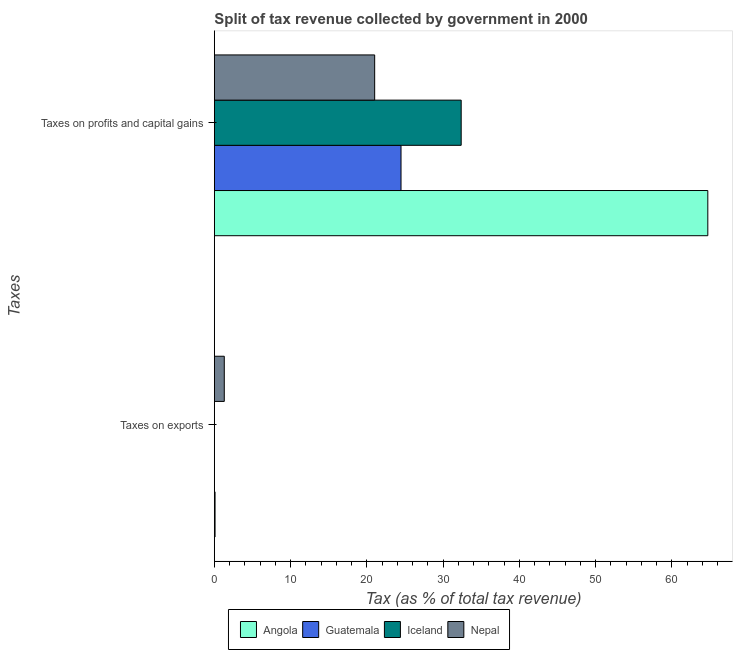How many different coloured bars are there?
Provide a short and direct response. 4. Are the number of bars per tick equal to the number of legend labels?
Keep it short and to the point. Yes. Are the number of bars on each tick of the Y-axis equal?
Give a very brief answer. Yes. How many bars are there on the 2nd tick from the top?
Make the answer very short. 4. What is the label of the 1st group of bars from the top?
Keep it short and to the point. Taxes on profits and capital gains. What is the percentage of revenue obtained from taxes on exports in Nepal?
Offer a terse response. 1.3. Across all countries, what is the maximum percentage of revenue obtained from taxes on exports?
Offer a terse response. 1.3. Across all countries, what is the minimum percentage of revenue obtained from taxes on exports?
Keep it short and to the point. 0.01. In which country was the percentage of revenue obtained from taxes on profits and capital gains maximum?
Ensure brevity in your answer.  Angola. What is the total percentage of revenue obtained from taxes on profits and capital gains in the graph?
Ensure brevity in your answer.  142.56. What is the difference between the percentage of revenue obtained from taxes on profits and capital gains in Angola and that in Iceland?
Give a very brief answer. 32.34. What is the difference between the percentage of revenue obtained from taxes on profits and capital gains in Nepal and the percentage of revenue obtained from taxes on exports in Guatemala?
Your answer should be compact. 21.01. What is the average percentage of revenue obtained from taxes on exports per country?
Make the answer very short. 0.35. What is the difference between the percentage of revenue obtained from taxes on exports and percentage of revenue obtained from taxes on profits and capital gains in Iceland?
Provide a succinct answer. -32.36. In how many countries, is the percentage of revenue obtained from taxes on exports greater than 30 %?
Your response must be concise. 0. What is the ratio of the percentage of revenue obtained from taxes on profits and capital gains in Nepal to that in Iceland?
Your answer should be very brief. 0.65. In how many countries, is the percentage of revenue obtained from taxes on profits and capital gains greater than the average percentage of revenue obtained from taxes on profits and capital gains taken over all countries?
Your answer should be compact. 1. What does the 4th bar from the top in Taxes on exports represents?
Offer a very short reply. Angola. What does the 2nd bar from the bottom in Taxes on profits and capital gains represents?
Your answer should be very brief. Guatemala. How many bars are there?
Make the answer very short. 8. Are all the bars in the graph horizontal?
Your answer should be very brief. Yes. What is the difference between two consecutive major ticks on the X-axis?
Provide a short and direct response. 10. Are the values on the major ticks of X-axis written in scientific E-notation?
Your answer should be compact. No. Does the graph contain any zero values?
Offer a terse response. No. How many legend labels are there?
Your answer should be very brief. 4. What is the title of the graph?
Give a very brief answer. Split of tax revenue collected by government in 2000. Does "Lao PDR" appear as one of the legend labels in the graph?
Your answer should be compact. No. What is the label or title of the X-axis?
Ensure brevity in your answer.  Tax (as % of total tax revenue). What is the label or title of the Y-axis?
Your answer should be very brief. Taxes. What is the Tax (as % of total tax revenue) of Angola in Taxes on exports?
Keep it short and to the point. 0.09. What is the Tax (as % of total tax revenue) of Guatemala in Taxes on exports?
Offer a terse response. 0.01. What is the Tax (as % of total tax revenue) of Iceland in Taxes on exports?
Offer a very short reply. 0.01. What is the Tax (as % of total tax revenue) in Nepal in Taxes on exports?
Keep it short and to the point. 1.3. What is the Tax (as % of total tax revenue) in Angola in Taxes on profits and capital gains?
Offer a very short reply. 64.7. What is the Tax (as % of total tax revenue) in Guatemala in Taxes on profits and capital gains?
Make the answer very short. 24.47. What is the Tax (as % of total tax revenue) in Iceland in Taxes on profits and capital gains?
Your answer should be very brief. 32.36. What is the Tax (as % of total tax revenue) in Nepal in Taxes on profits and capital gains?
Give a very brief answer. 21.02. Across all Taxes, what is the maximum Tax (as % of total tax revenue) of Angola?
Give a very brief answer. 64.7. Across all Taxes, what is the maximum Tax (as % of total tax revenue) of Guatemala?
Offer a terse response. 24.47. Across all Taxes, what is the maximum Tax (as % of total tax revenue) of Iceland?
Provide a succinct answer. 32.36. Across all Taxes, what is the maximum Tax (as % of total tax revenue) in Nepal?
Offer a very short reply. 21.02. Across all Taxes, what is the minimum Tax (as % of total tax revenue) of Angola?
Provide a succinct answer. 0.09. Across all Taxes, what is the minimum Tax (as % of total tax revenue) in Guatemala?
Make the answer very short. 0.01. Across all Taxes, what is the minimum Tax (as % of total tax revenue) in Iceland?
Make the answer very short. 0.01. Across all Taxes, what is the minimum Tax (as % of total tax revenue) of Nepal?
Make the answer very short. 1.3. What is the total Tax (as % of total tax revenue) of Angola in the graph?
Provide a succinct answer. 64.79. What is the total Tax (as % of total tax revenue) in Guatemala in the graph?
Provide a succinct answer. 24.48. What is the total Tax (as % of total tax revenue) of Iceland in the graph?
Ensure brevity in your answer.  32.37. What is the total Tax (as % of total tax revenue) in Nepal in the graph?
Make the answer very short. 22.32. What is the difference between the Tax (as % of total tax revenue) of Angola in Taxes on exports and that in Taxes on profits and capital gains?
Provide a succinct answer. -64.61. What is the difference between the Tax (as % of total tax revenue) of Guatemala in Taxes on exports and that in Taxes on profits and capital gains?
Keep it short and to the point. -24.46. What is the difference between the Tax (as % of total tax revenue) of Iceland in Taxes on exports and that in Taxes on profits and capital gains?
Make the answer very short. -32.36. What is the difference between the Tax (as % of total tax revenue) of Nepal in Taxes on exports and that in Taxes on profits and capital gains?
Ensure brevity in your answer.  -19.72. What is the difference between the Tax (as % of total tax revenue) in Angola in Taxes on exports and the Tax (as % of total tax revenue) in Guatemala in Taxes on profits and capital gains?
Your response must be concise. -24.38. What is the difference between the Tax (as % of total tax revenue) in Angola in Taxes on exports and the Tax (as % of total tax revenue) in Iceland in Taxes on profits and capital gains?
Keep it short and to the point. -32.27. What is the difference between the Tax (as % of total tax revenue) in Angola in Taxes on exports and the Tax (as % of total tax revenue) in Nepal in Taxes on profits and capital gains?
Provide a succinct answer. -20.93. What is the difference between the Tax (as % of total tax revenue) in Guatemala in Taxes on exports and the Tax (as % of total tax revenue) in Iceland in Taxes on profits and capital gains?
Provide a short and direct response. -32.35. What is the difference between the Tax (as % of total tax revenue) of Guatemala in Taxes on exports and the Tax (as % of total tax revenue) of Nepal in Taxes on profits and capital gains?
Provide a short and direct response. -21.01. What is the difference between the Tax (as % of total tax revenue) in Iceland in Taxes on exports and the Tax (as % of total tax revenue) in Nepal in Taxes on profits and capital gains?
Your response must be concise. -21.01. What is the average Tax (as % of total tax revenue) of Angola per Taxes?
Make the answer very short. 32.4. What is the average Tax (as % of total tax revenue) of Guatemala per Taxes?
Provide a succinct answer. 12.24. What is the average Tax (as % of total tax revenue) in Iceland per Taxes?
Provide a succinct answer. 16.19. What is the average Tax (as % of total tax revenue) in Nepal per Taxes?
Your answer should be very brief. 11.16. What is the difference between the Tax (as % of total tax revenue) in Angola and Tax (as % of total tax revenue) in Guatemala in Taxes on exports?
Ensure brevity in your answer.  0.08. What is the difference between the Tax (as % of total tax revenue) of Angola and Tax (as % of total tax revenue) of Iceland in Taxes on exports?
Keep it short and to the point. 0.09. What is the difference between the Tax (as % of total tax revenue) of Angola and Tax (as % of total tax revenue) of Nepal in Taxes on exports?
Provide a succinct answer. -1.21. What is the difference between the Tax (as % of total tax revenue) of Guatemala and Tax (as % of total tax revenue) of Iceland in Taxes on exports?
Your answer should be very brief. 0. What is the difference between the Tax (as % of total tax revenue) of Guatemala and Tax (as % of total tax revenue) of Nepal in Taxes on exports?
Ensure brevity in your answer.  -1.29. What is the difference between the Tax (as % of total tax revenue) of Iceland and Tax (as % of total tax revenue) of Nepal in Taxes on exports?
Your response must be concise. -1.3. What is the difference between the Tax (as % of total tax revenue) of Angola and Tax (as % of total tax revenue) of Guatemala in Taxes on profits and capital gains?
Offer a very short reply. 40.23. What is the difference between the Tax (as % of total tax revenue) in Angola and Tax (as % of total tax revenue) in Iceland in Taxes on profits and capital gains?
Ensure brevity in your answer.  32.34. What is the difference between the Tax (as % of total tax revenue) in Angola and Tax (as % of total tax revenue) in Nepal in Taxes on profits and capital gains?
Ensure brevity in your answer.  43.68. What is the difference between the Tax (as % of total tax revenue) in Guatemala and Tax (as % of total tax revenue) in Iceland in Taxes on profits and capital gains?
Make the answer very short. -7.89. What is the difference between the Tax (as % of total tax revenue) of Guatemala and Tax (as % of total tax revenue) of Nepal in Taxes on profits and capital gains?
Provide a short and direct response. 3.45. What is the difference between the Tax (as % of total tax revenue) in Iceland and Tax (as % of total tax revenue) in Nepal in Taxes on profits and capital gains?
Your response must be concise. 11.34. What is the ratio of the Tax (as % of total tax revenue) in Angola in Taxes on exports to that in Taxes on profits and capital gains?
Offer a terse response. 0. What is the ratio of the Tax (as % of total tax revenue) of Iceland in Taxes on exports to that in Taxes on profits and capital gains?
Ensure brevity in your answer.  0. What is the ratio of the Tax (as % of total tax revenue) in Nepal in Taxes on exports to that in Taxes on profits and capital gains?
Keep it short and to the point. 0.06. What is the difference between the highest and the second highest Tax (as % of total tax revenue) in Angola?
Give a very brief answer. 64.61. What is the difference between the highest and the second highest Tax (as % of total tax revenue) of Guatemala?
Ensure brevity in your answer.  24.46. What is the difference between the highest and the second highest Tax (as % of total tax revenue) in Iceland?
Make the answer very short. 32.36. What is the difference between the highest and the second highest Tax (as % of total tax revenue) in Nepal?
Provide a short and direct response. 19.72. What is the difference between the highest and the lowest Tax (as % of total tax revenue) in Angola?
Provide a short and direct response. 64.61. What is the difference between the highest and the lowest Tax (as % of total tax revenue) in Guatemala?
Provide a short and direct response. 24.46. What is the difference between the highest and the lowest Tax (as % of total tax revenue) of Iceland?
Make the answer very short. 32.36. What is the difference between the highest and the lowest Tax (as % of total tax revenue) in Nepal?
Ensure brevity in your answer.  19.72. 